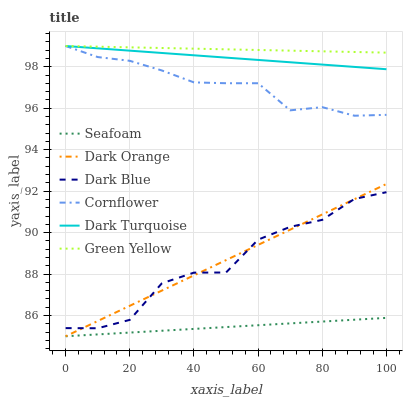Does Seafoam have the minimum area under the curve?
Answer yes or no. Yes. Does Green Yellow have the maximum area under the curve?
Answer yes or no. Yes. Does Cornflower have the minimum area under the curve?
Answer yes or no. No. Does Cornflower have the maximum area under the curve?
Answer yes or no. No. Is Green Yellow the smoothest?
Answer yes or no. Yes. Is Dark Blue the roughest?
Answer yes or no. Yes. Is Cornflower the smoothest?
Answer yes or no. No. Is Cornflower the roughest?
Answer yes or no. No. Does Cornflower have the lowest value?
Answer yes or no. No. Does Green Yellow have the highest value?
Answer yes or no. Yes. Does Seafoam have the highest value?
Answer yes or no. No. Is Dark Blue less than Green Yellow?
Answer yes or no. Yes. Is Dark Blue greater than Seafoam?
Answer yes or no. Yes. Does Dark Blue intersect Green Yellow?
Answer yes or no. No. 